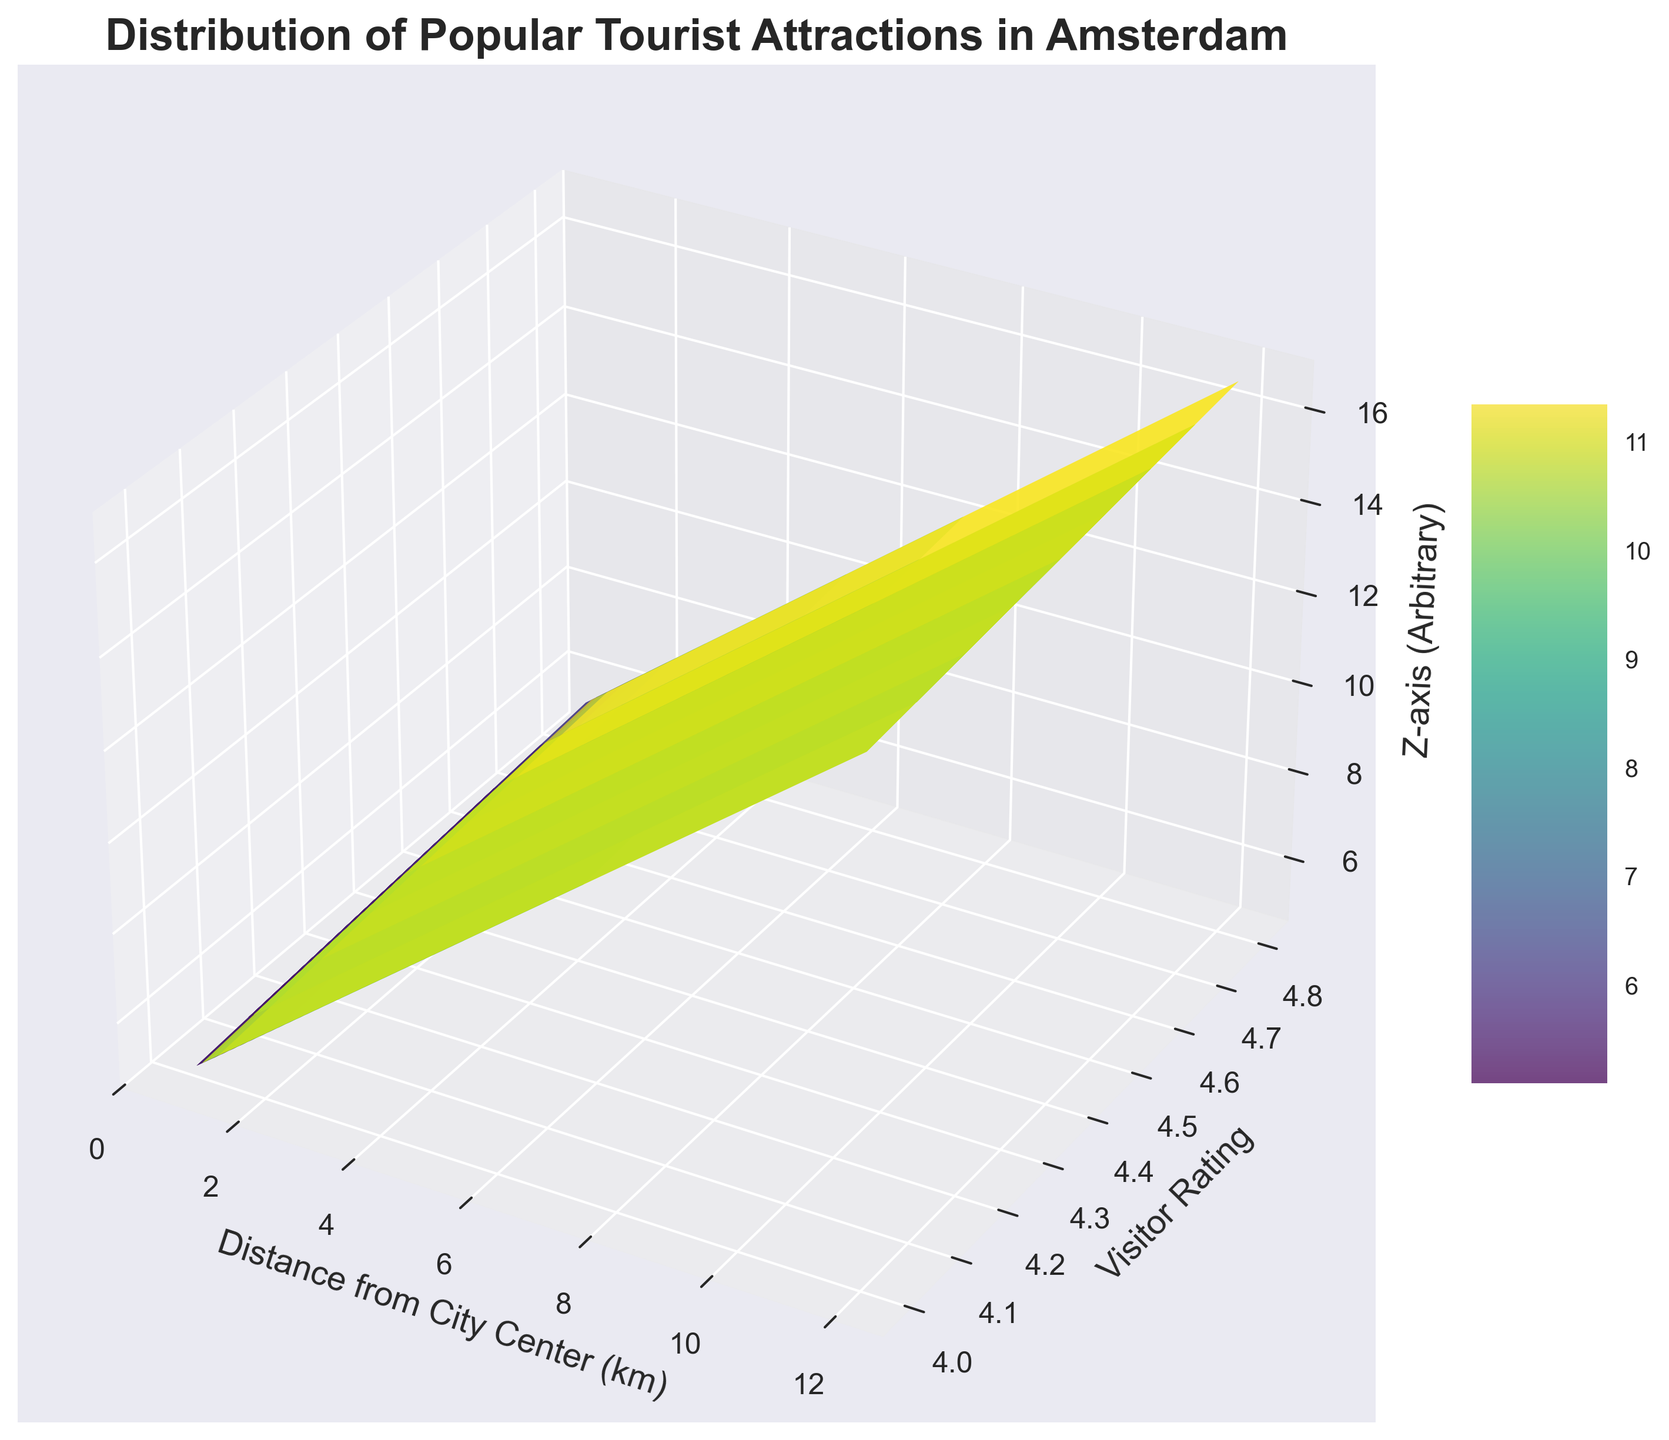What is the general relationship between visitor ratings and proximity to the city center? The 3D surface plot allows us to observe the combined influence of ratings and distance on the Z-axis. By examining the surface gradient, we can see if there's a general trend, but the actual specifics depend on interpreting the overall shape and orientation of the surface. It appears that higher-rated attractions are often closer to the center but there's a variable trend due to the combined influence of distance.
Answer: Higher-rated attractions are generally closer to the center, but with some variability Which attraction is the farthest from the city center and what is its rating? By locating the point with the maximum distance on the X-axis and identifying its corresponding rating and name, we see that the Zaanse Schans is the farthest from the city center with a distance of 12.0 km. Its rating is recorded at 4.7.
Answer: Zaanse Schans, 4.7 What range in visitor ratings can be observed for attractions less than 2 km away from the city center? Looking at the X-axis for distance values less than 2 km, we can then note the range of corresponding Y-axis values (ratings). Attractions less than 2 km away have ratings that range from around 4.1 to 4.8.
Answer: 4.1 to 4.8 How does the Royal Palace of Amsterdam compare with the Anne Frank House in terms of distance from the city center and visitor rating? We compare the X and Y coordinates of both points. The Royal Palace of Amsterdam has a distance of 1.1 km and a rating of 4.3, whereas the Anne Frank House has a distance of 1.2 km and a rating of 4.6. Thus, the Anne Frank House is slightly farther but has a higher rating.
Answer: Anne Frank House is farther with a higher rating Which attraction might have the highest combined influence on the Z-axis and what are its coordinates (distance and rating)? By identifying the peak of the Z-axis surface plot, we estimate the coordinates which likely have the highest sum. The prominent attraction here is the Van Gogh Museum with coordinates (1.5, 4.8), resulting in a strong influence on the Z-axis.
Answer: Van Gogh Museum, (1.5, 4.8) What is the average visitor rating for attractions located between 1 and 2 km from the city center? We need to select attractions with distances between 1 and 2 km, then calculate the average of their ratings. These attractions are Rijksmuseum, Van Gogh Museum, St. Nicholas Basilica, Vondelpark, Rembrandt House Museum, Amsterdam Dungeon, Royal Palace of Amsterdam, Westerkerk, Ons' Lieve Heer op Solder, Anne Frank House, Museum of the Canals, Magere Brug, Electric Ladyland Fluorescent Art Museum, Foam - Photography Museum and Hermitage Amsterdam. Calculating the average rating among these 14 data points: (4.7 + 4.8 + 4.5 + 4.5 + 4.2 + 4.2 + 4.3 + 4.4 + 4.4 + 4.6 + 4.3 + 4.4 + 4.0 + 4.2 + 4.3) / 15 = 4.38.
Answer: 4.38 How would you describe the spread of attractions based on distance from city center? By examining the X-axis spread, we can observe that most attractions are clustered within 3 km of the city center, with few outliers like Zaanse Schans at 12 km and Molen van Sloten at 7.5 km. This suggests that most tourist hotspots are quite centralized.
Answer: Most attractions are within 3 km, with a few outliers Which attraction has the highest rating at a distance of more than 2 km from the city center? By filtering attractions with distances greater than 2 km and noting their ratings, we find that Rijksmuseum stands out with the highest rating of 4.7 among those attractions.
Answer: Rijksmuseum, 4.7 